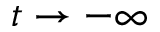Convert formula to latex. <formula><loc_0><loc_0><loc_500><loc_500>t \to - \infty</formula> 